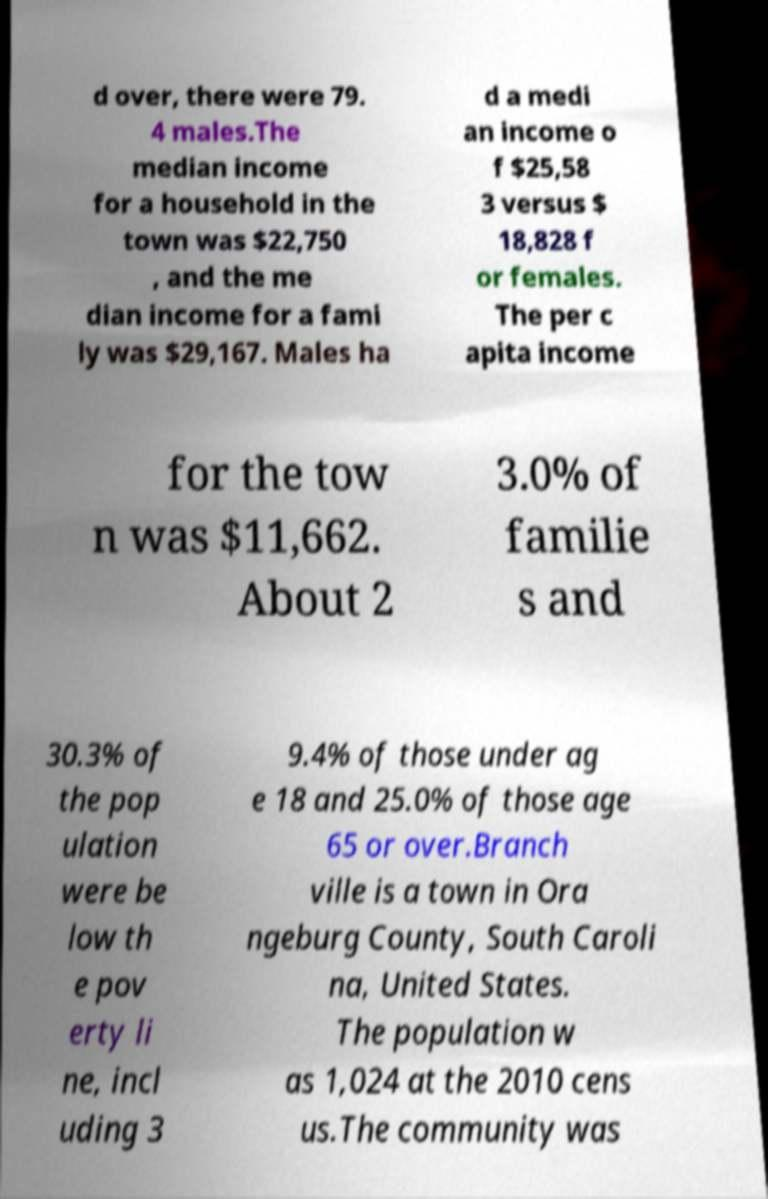Can you accurately transcribe the text from the provided image for me? d over, there were 79. 4 males.The median income for a household in the town was $22,750 , and the me dian income for a fami ly was $29,167. Males ha d a medi an income o f $25,58 3 versus $ 18,828 f or females. The per c apita income for the tow n was $11,662. About 2 3.0% of familie s and 30.3% of the pop ulation were be low th e pov erty li ne, incl uding 3 9.4% of those under ag e 18 and 25.0% of those age 65 or over.Branch ville is a town in Ora ngeburg County, South Caroli na, United States. The population w as 1,024 at the 2010 cens us.The community was 